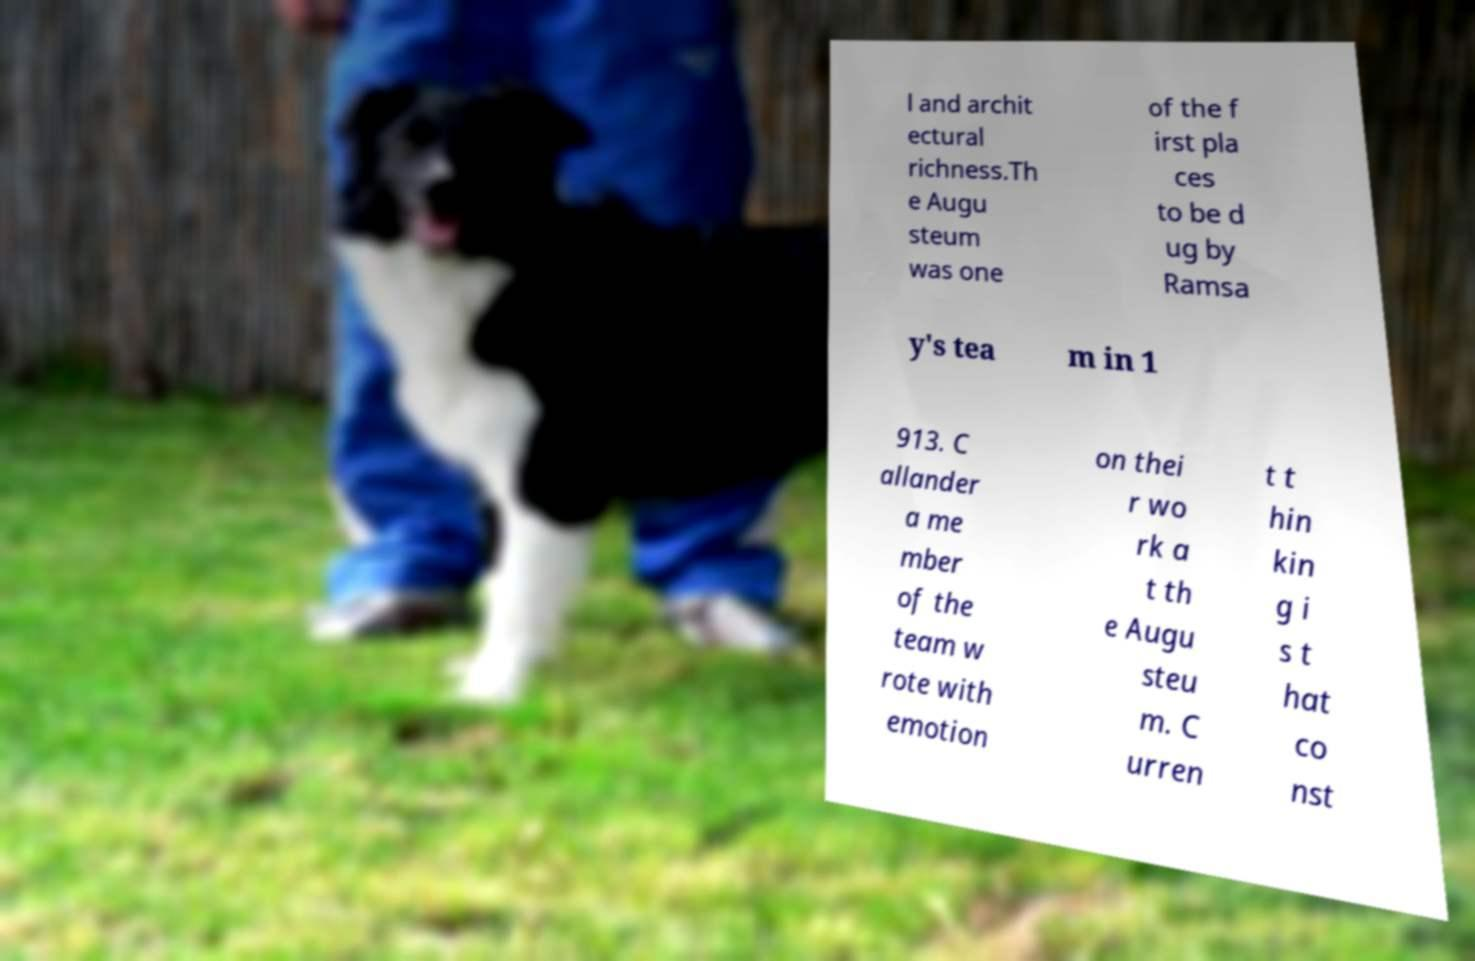Can you accurately transcribe the text from the provided image for me? l and archit ectural richness.Th e Augu steum was one of the f irst pla ces to be d ug by Ramsa y's tea m in 1 913. C allander a me mber of the team w rote with emotion on thei r wo rk a t th e Augu steu m. C urren t t hin kin g i s t hat co nst 